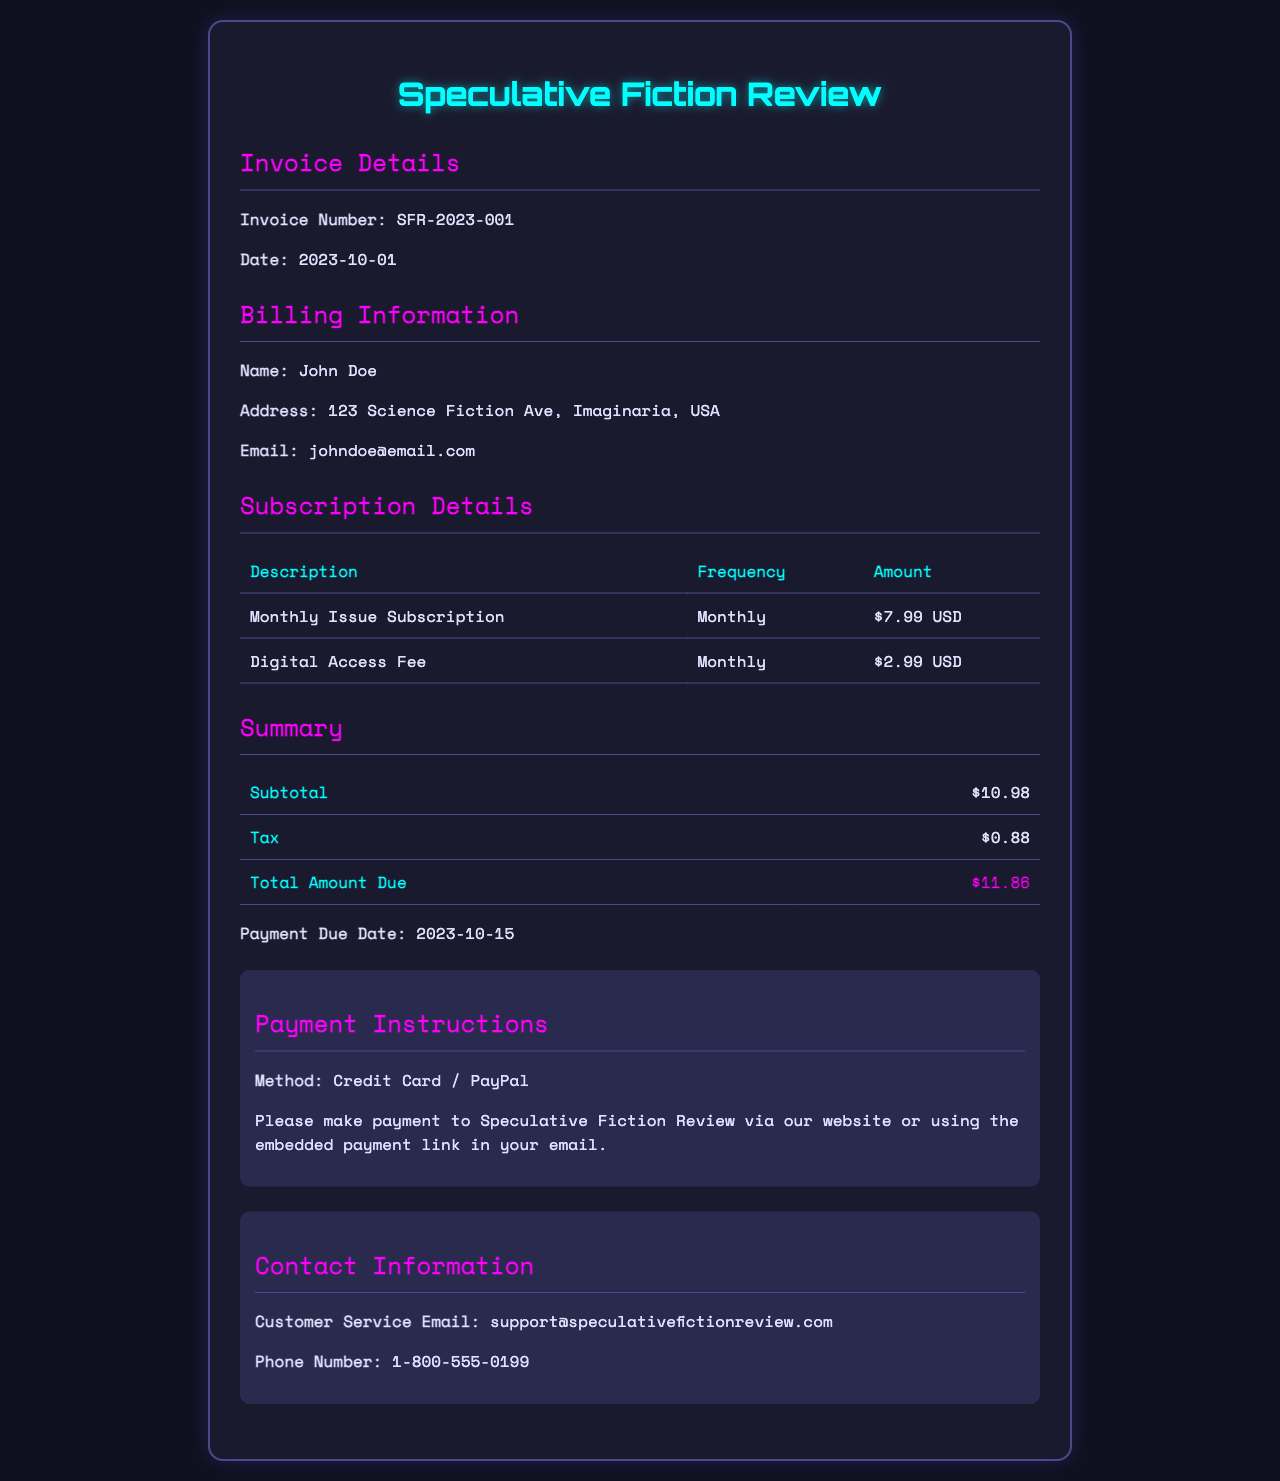What is the invoice number? The invoice number is provided under the Invoice Details section.
Answer: SFR-2023-001 What is the date of the invoice? The date of the invoice is also found in the Invoice Details section.
Answer: 2023-10-01 What is the total amount due? The total amount due is calculated in the Summary section of the invoice.
Answer: $11.86 What is the name of the subscriber? The subscriber's name is listed in the Billing Information section.
Answer: John Doe How much is the monthly issue subscription? The amount for the monthly issue subscription is presented in the Subscription Details section.
Answer: $7.99 USD What is the payment due date? The payment due date is mentioned in the Summary section.
Answer: 2023-10-15 What payment methods are accepted? The payment methods are specified in the Payment Instructions section of the invoice.
Answer: Credit Card / PayPal What is the subtotal before tax? The subtotal is detailed in the Summary section.
Answer: $10.98 How much is the digital access fee? The digital access fee is listed in the Subscription Details section.
Answer: $2.99 USD 